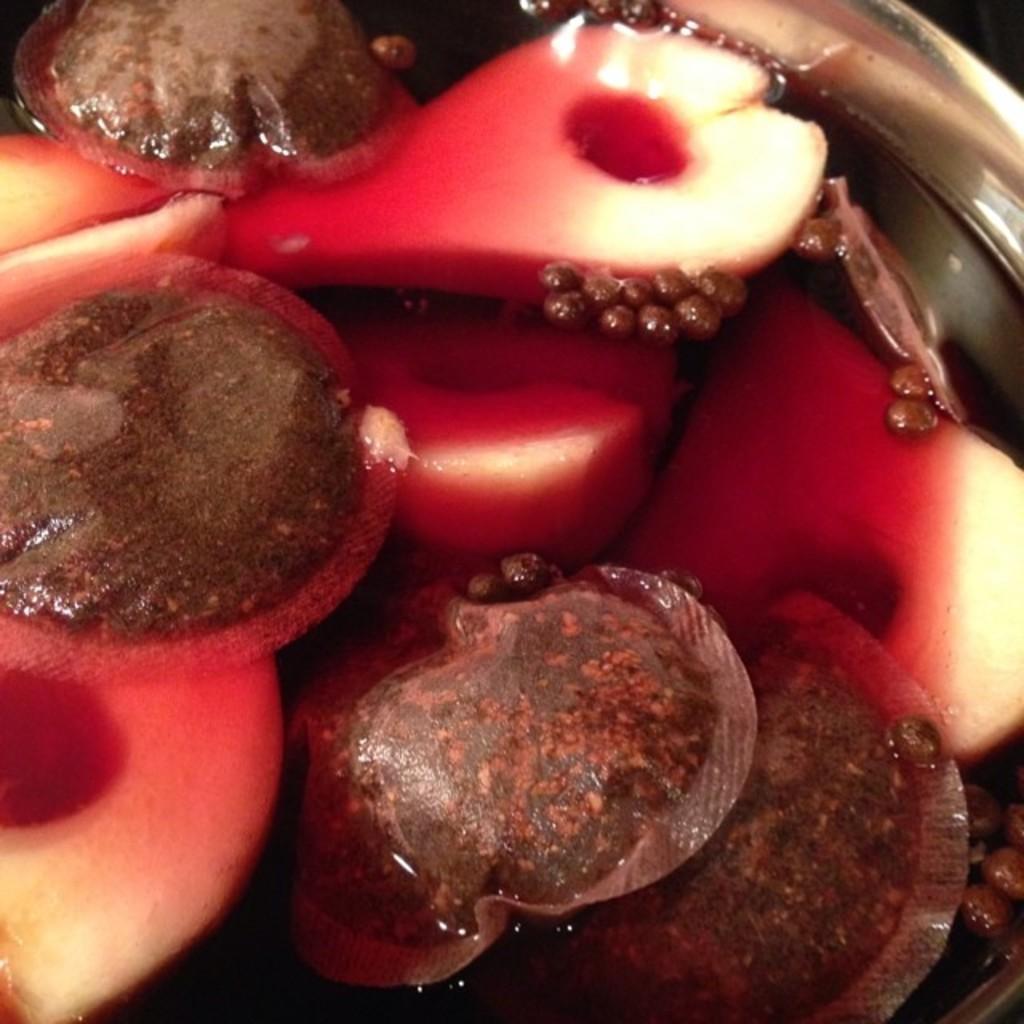How would you summarize this image in a sentence or two? In this picture we can see water and fruits in the bowl. 